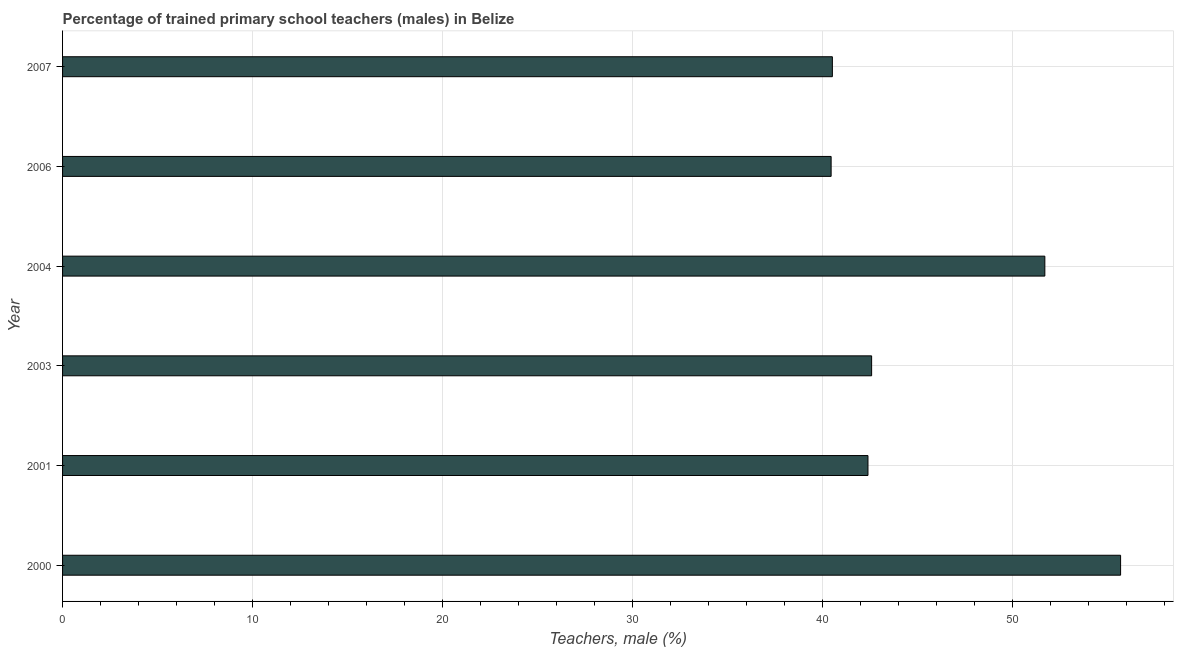What is the title of the graph?
Keep it short and to the point. Percentage of trained primary school teachers (males) in Belize. What is the label or title of the X-axis?
Offer a terse response. Teachers, male (%). What is the label or title of the Y-axis?
Ensure brevity in your answer.  Year. What is the percentage of trained male teachers in 2004?
Offer a very short reply. 51.71. Across all years, what is the maximum percentage of trained male teachers?
Provide a short and direct response. 55.7. Across all years, what is the minimum percentage of trained male teachers?
Provide a short and direct response. 40.46. In which year was the percentage of trained male teachers maximum?
Your answer should be compact. 2000. What is the sum of the percentage of trained male teachers?
Provide a succinct answer. 273.4. What is the difference between the percentage of trained male teachers in 2001 and 2007?
Your answer should be very brief. 1.87. What is the average percentage of trained male teachers per year?
Offer a very short reply. 45.57. What is the median percentage of trained male teachers?
Offer a very short reply. 42.5. What is the ratio of the percentage of trained male teachers in 2000 to that in 2006?
Give a very brief answer. 1.38. Is the difference between the percentage of trained male teachers in 2001 and 2004 greater than the difference between any two years?
Give a very brief answer. No. What is the difference between the highest and the second highest percentage of trained male teachers?
Give a very brief answer. 3.99. Is the sum of the percentage of trained male teachers in 2006 and 2007 greater than the maximum percentage of trained male teachers across all years?
Offer a very short reply. Yes. What is the difference between the highest and the lowest percentage of trained male teachers?
Give a very brief answer. 15.24. In how many years, is the percentage of trained male teachers greater than the average percentage of trained male teachers taken over all years?
Give a very brief answer. 2. How many years are there in the graph?
Ensure brevity in your answer.  6. What is the difference between two consecutive major ticks on the X-axis?
Your answer should be compact. 10. What is the Teachers, male (%) in 2000?
Offer a terse response. 55.7. What is the Teachers, male (%) of 2001?
Offer a terse response. 42.4. What is the Teachers, male (%) of 2003?
Provide a succinct answer. 42.59. What is the Teachers, male (%) in 2004?
Provide a short and direct response. 51.71. What is the Teachers, male (%) in 2006?
Keep it short and to the point. 40.46. What is the Teachers, male (%) in 2007?
Your answer should be compact. 40.53. What is the difference between the Teachers, male (%) in 2000 and 2001?
Provide a short and direct response. 13.3. What is the difference between the Teachers, male (%) in 2000 and 2003?
Keep it short and to the point. 13.11. What is the difference between the Teachers, male (%) in 2000 and 2004?
Offer a very short reply. 3.99. What is the difference between the Teachers, male (%) in 2000 and 2006?
Offer a very short reply. 15.24. What is the difference between the Teachers, male (%) in 2000 and 2007?
Provide a short and direct response. 15.17. What is the difference between the Teachers, male (%) in 2001 and 2003?
Offer a terse response. -0.19. What is the difference between the Teachers, male (%) in 2001 and 2004?
Your response must be concise. -9.31. What is the difference between the Teachers, male (%) in 2001 and 2006?
Ensure brevity in your answer.  1.94. What is the difference between the Teachers, male (%) in 2001 and 2007?
Your answer should be very brief. 1.87. What is the difference between the Teachers, male (%) in 2003 and 2004?
Your response must be concise. -9.12. What is the difference between the Teachers, male (%) in 2003 and 2006?
Offer a terse response. 2.13. What is the difference between the Teachers, male (%) in 2003 and 2007?
Your response must be concise. 2.07. What is the difference between the Teachers, male (%) in 2004 and 2006?
Your response must be concise. 11.25. What is the difference between the Teachers, male (%) in 2004 and 2007?
Ensure brevity in your answer.  11.19. What is the difference between the Teachers, male (%) in 2006 and 2007?
Your answer should be very brief. -0.07. What is the ratio of the Teachers, male (%) in 2000 to that in 2001?
Offer a terse response. 1.31. What is the ratio of the Teachers, male (%) in 2000 to that in 2003?
Your response must be concise. 1.31. What is the ratio of the Teachers, male (%) in 2000 to that in 2004?
Provide a succinct answer. 1.08. What is the ratio of the Teachers, male (%) in 2000 to that in 2006?
Provide a succinct answer. 1.38. What is the ratio of the Teachers, male (%) in 2000 to that in 2007?
Your answer should be very brief. 1.37. What is the ratio of the Teachers, male (%) in 2001 to that in 2004?
Give a very brief answer. 0.82. What is the ratio of the Teachers, male (%) in 2001 to that in 2006?
Your response must be concise. 1.05. What is the ratio of the Teachers, male (%) in 2001 to that in 2007?
Your answer should be very brief. 1.05. What is the ratio of the Teachers, male (%) in 2003 to that in 2004?
Offer a very short reply. 0.82. What is the ratio of the Teachers, male (%) in 2003 to that in 2006?
Make the answer very short. 1.05. What is the ratio of the Teachers, male (%) in 2003 to that in 2007?
Provide a short and direct response. 1.05. What is the ratio of the Teachers, male (%) in 2004 to that in 2006?
Offer a very short reply. 1.28. What is the ratio of the Teachers, male (%) in 2004 to that in 2007?
Your response must be concise. 1.28. What is the ratio of the Teachers, male (%) in 2006 to that in 2007?
Offer a terse response. 1. 